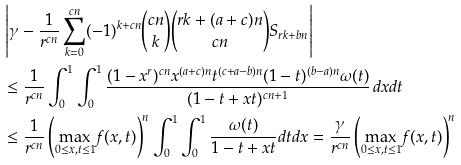Convert formula to latex. <formula><loc_0><loc_0><loc_500><loc_500>& \left | \gamma - \frac { 1 } { r ^ { c n } } \sum _ { k = 0 } ^ { c n } ( - 1 ) ^ { k + c n } \binom { c n } { k } \binom { r k + ( a + c ) n } { c n } S _ { r k + b n } \right | \\ & \leq \frac { 1 } { r ^ { c n } } \int _ { 0 } ^ { 1 } \int _ { 0 } ^ { 1 } \frac { ( 1 - x ^ { r } ) ^ { c n } x ^ { ( a + c ) n } t ^ { ( c + a - b ) n } ( 1 - t ) ^ { ( b - a ) n } \omega ( t ) } { ( 1 - t + x t ) ^ { c n + 1 } } \, d x d t \\ & \leq \frac { 1 } { r ^ { c n } } \left ( \underset { 0 \leq x , t \leq 1 } { \max } f ( x , t ) \right ) ^ { n } \int _ { 0 } ^ { 1 } \int _ { 0 } ^ { 1 } \frac { \omega ( t ) } { 1 - t + x t } d t d x = \frac { \gamma } { r ^ { c n } } \left ( \underset { 0 \leq x , t \leq 1 } { \max } f ( x , t ) \right ) ^ { n }</formula> 